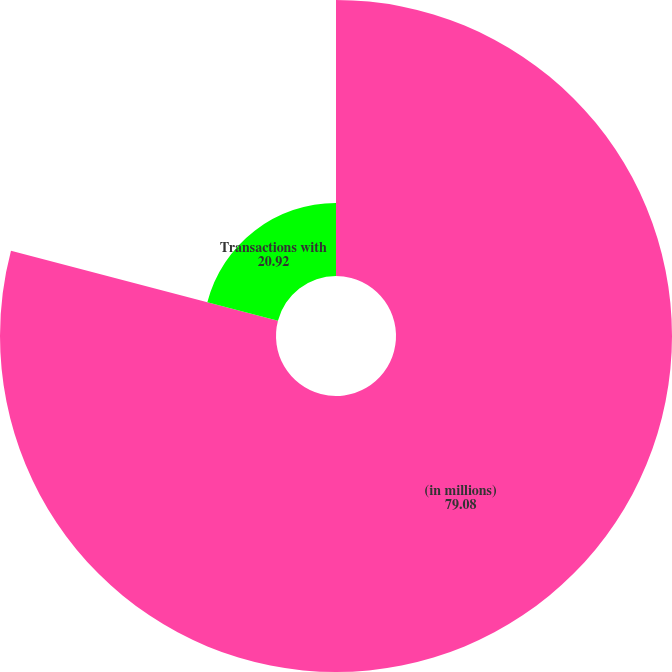Convert chart. <chart><loc_0><loc_0><loc_500><loc_500><pie_chart><fcel>(in millions)<fcel>Transactions with<nl><fcel>79.08%<fcel>20.92%<nl></chart> 